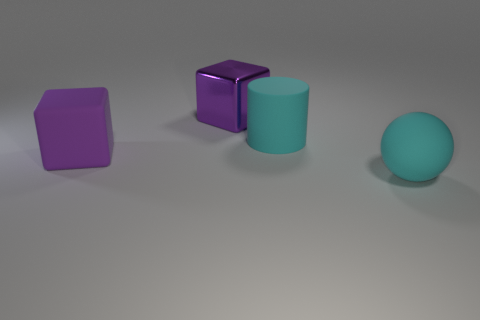What number of other large matte things have the same shape as the big purple rubber object?
Offer a very short reply. 0. What is the material of the cylinder?
Your answer should be compact. Rubber. Is the number of cyan rubber cylinders in front of the big cyan cylinder the same as the number of large brown objects?
Give a very brief answer. Yes. There is another purple thing that is the same size as the purple metal object; what shape is it?
Provide a short and direct response. Cube. There is a large purple object in front of the big rubber cylinder; are there any big rubber balls that are left of it?
Provide a short and direct response. No. How many tiny objects are either red shiny blocks or cyan things?
Your answer should be compact. 0. Are there any green cubes of the same size as the rubber cylinder?
Provide a short and direct response. No. What number of metal objects are big cylinders or yellow things?
Give a very brief answer. 0. The other thing that is the same color as the large metallic thing is what shape?
Your answer should be very brief. Cube. How many red shiny cylinders are there?
Ensure brevity in your answer.  0. 